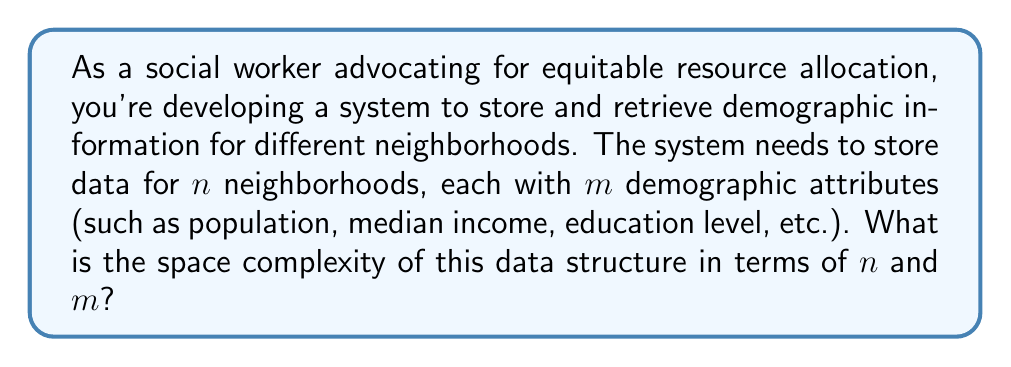Give your solution to this math problem. To analyze the space complexity of this data structure, let's break it down step-by-step:

1. We have $n$ neighborhoods, each requiring its own entry in our data structure.

2. For each neighborhood, we need to store $m$ demographic attributes.

3. Assuming each attribute is stored as a fixed-size value (e.g., an integer or float), the space required for each attribute is constant, let's call it $c$.

4. For a single neighborhood, the space required is $m * c$.

5. For all $n$ neighborhoods, the total space required is $n * (m * c)$.

6. Simplifying this expression: $n * m * c$.

7. In Big O notation, we ignore constant factors. Therefore, we can remove $c$ from our expression.

8. The resulting space complexity is $O(n * m)$.

This space complexity indicates that the storage requirement grows linearly with both the number of neighborhoods and the number of attributes per neighborhood. This analysis helps social workers understand the scalability of their data storage system as they expand their demographic data collection efforts across more neighborhoods or include more detailed attributes.
Answer: $O(n * m)$, where $n$ is the number of neighborhoods and $m$ is the number of demographic attributes per neighborhood. 